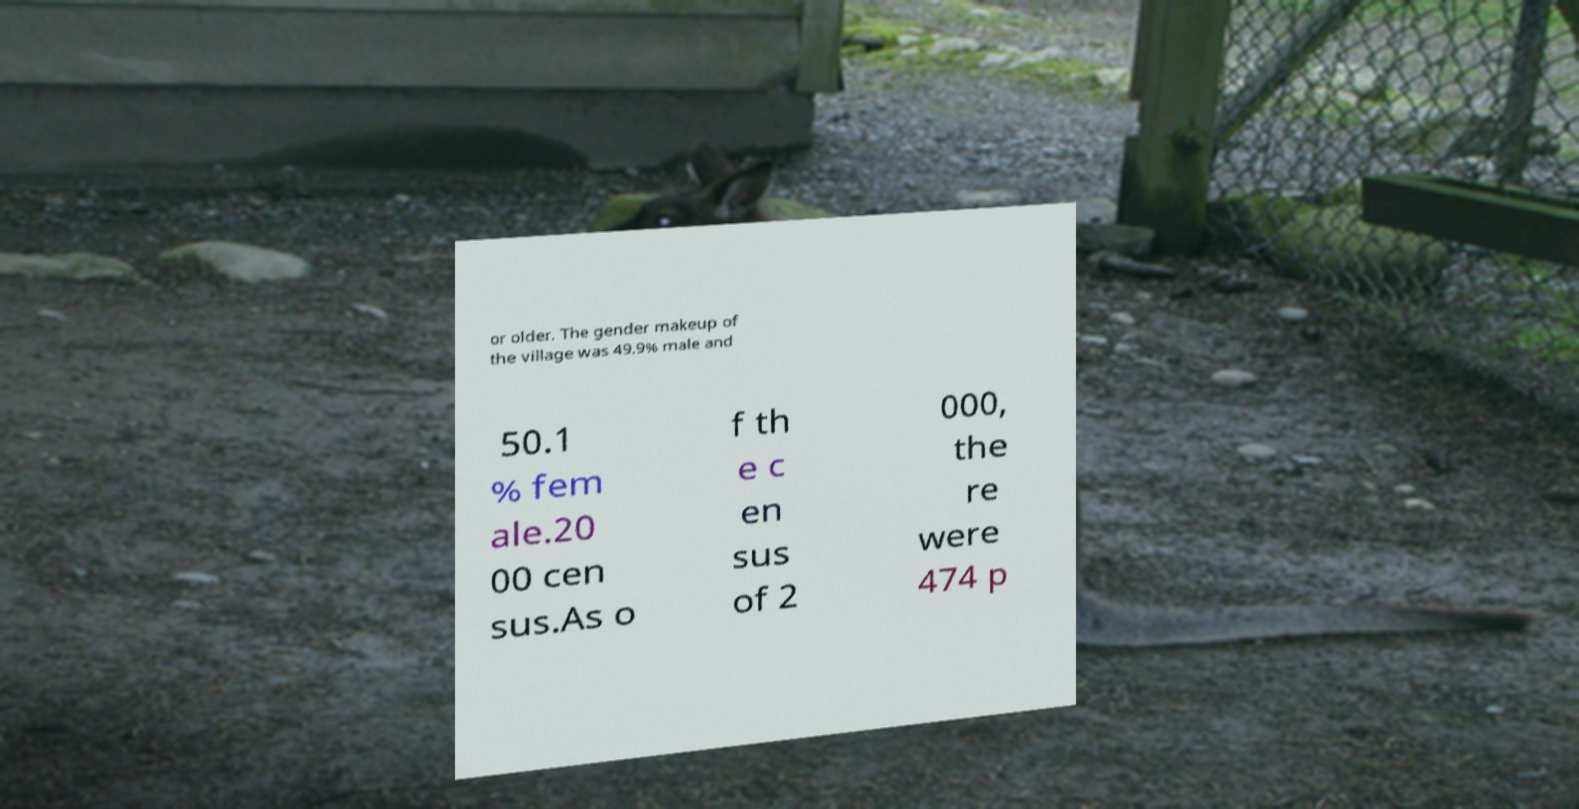Please read and relay the text visible in this image. What does it say? or older. The gender makeup of the village was 49.9% male and 50.1 % fem ale.20 00 cen sus.As o f th e c en sus of 2 000, the re were 474 p 